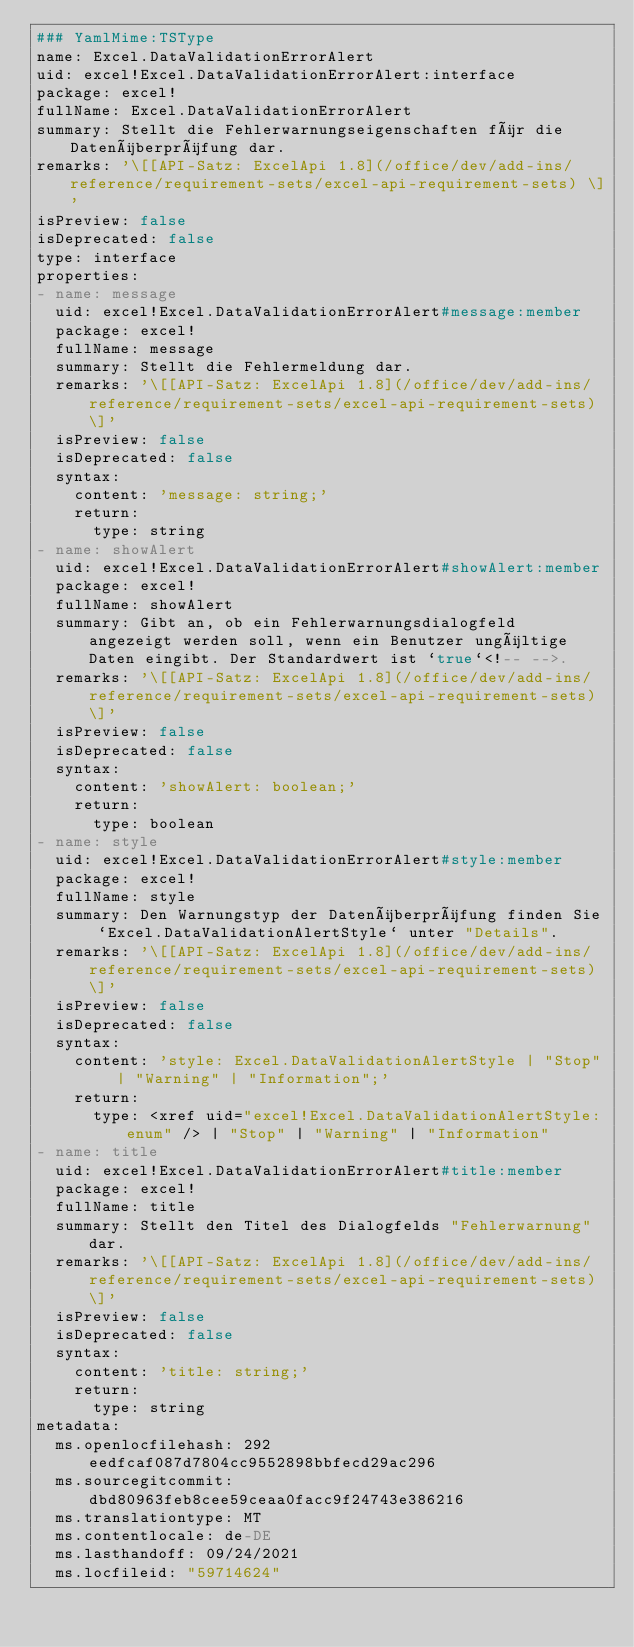<code> <loc_0><loc_0><loc_500><loc_500><_YAML_>### YamlMime:TSType
name: Excel.DataValidationErrorAlert
uid: excel!Excel.DataValidationErrorAlert:interface
package: excel!
fullName: Excel.DataValidationErrorAlert
summary: Stellt die Fehlerwarnungseigenschaften für die Datenüberprüfung dar.
remarks: '\[[API-Satz: ExcelApi 1.8](/office/dev/add-ins/reference/requirement-sets/excel-api-requirement-sets) \]'
isPreview: false
isDeprecated: false
type: interface
properties:
- name: message
  uid: excel!Excel.DataValidationErrorAlert#message:member
  package: excel!
  fullName: message
  summary: Stellt die Fehlermeldung dar.
  remarks: '\[[API-Satz: ExcelApi 1.8](/office/dev/add-ins/reference/requirement-sets/excel-api-requirement-sets) \]'
  isPreview: false
  isDeprecated: false
  syntax:
    content: 'message: string;'
    return:
      type: string
- name: showAlert
  uid: excel!Excel.DataValidationErrorAlert#showAlert:member
  package: excel!
  fullName: showAlert
  summary: Gibt an, ob ein Fehlerwarnungsdialogfeld angezeigt werden soll, wenn ein Benutzer ungültige Daten eingibt. Der Standardwert ist `true`<!-- -->.
  remarks: '\[[API-Satz: ExcelApi 1.8](/office/dev/add-ins/reference/requirement-sets/excel-api-requirement-sets) \]'
  isPreview: false
  isDeprecated: false
  syntax:
    content: 'showAlert: boolean;'
    return:
      type: boolean
- name: style
  uid: excel!Excel.DataValidationErrorAlert#style:member
  package: excel!
  fullName: style
  summary: Den Warnungstyp der Datenüberprüfung finden Sie `Excel.DataValidationAlertStyle` unter "Details".
  remarks: '\[[API-Satz: ExcelApi 1.8](/office/dev/add-ins/reference/requirement-sets/excel-api-requirement-sets) \]'
  isPreview: false
  isDeprecated: false
  syntax:
    content: 'style: Excel.DataValidationAlertStyle | "Stop" | "Warning" | "Information";'
    return:
      type: <xref uid="excel!Excel.DataValidationAlertStyle:enum" /> | "Stop" | "Warning" | "Information"
- name: title
  uid: excel!Excel.DataValidationErrorAlert#title:member
  package: excel!
  fullName: title
  summary: Stellt den Titel des Dialogfelds "Fehlerwarnung" dar.
  remarks: '\[[API-Satz: ExcelApi 1.8](/office/dev/add-ins/reference/requirement-sets/excel-api-requirement-sets) \]'
  isPreview: false
  isDeprecated: false
  syntax:
    content: 'title: string;'
    return:
      type: string
metadata:
  ms.openlocfilehash: 292eedfcaf087d7804cc9552898bbfecd29ac296
  ms.sourcegitcommit: dbd80963feb8cee59ceaa0facc9f24743e386216
  ms.translationtype: MT
  ms.contentlocale: de-DE
  ms.lasthandoff: 09/24/2021
  ms.locfileid: "59714624"
</code> 